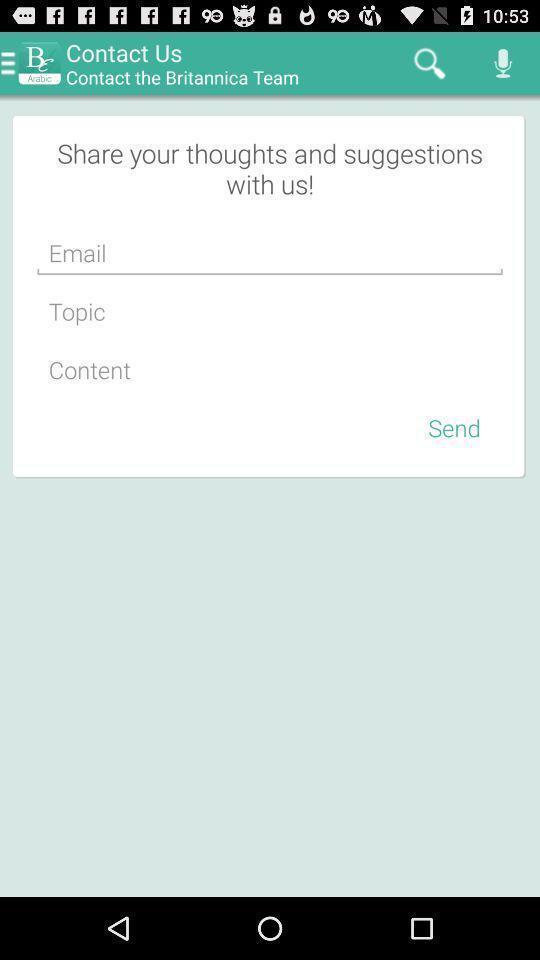Please provide a description for this image. Page displays to share suggestions in app. 